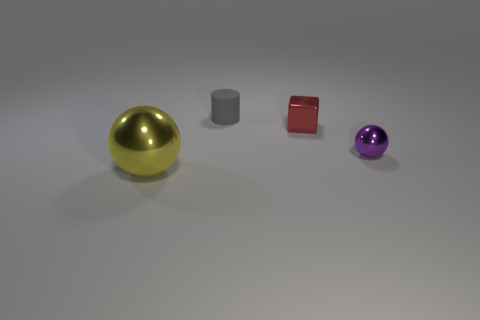What is the block made of?
Your answer should be very brief. Metal. What number of other objects are the same material as the tiny block?
Give a very brief answer. 2. How many red cubes are there?
Give a very brief answer. 1. Is the material of the thing that is in front of the tiny purple metallic ball the same as the tiny red thing?
Offer a very short reply. Yes. Is the number of large metal spheres on the left side of the tiny metallic block greater than the number of cylinders behind the tiny gray thing?
Your answer should be very brief. Yes. The block has what size?
Provide a succinct answer. Small. The purple thing that is the same material as the small block is what shape?
Provide a succinct answer. Sphere. There is a metal thing on the left side of the small gray cylinder; does it have the same shape as the small purple thing?
Make the answer very short. Yes. What number of objects are purple matte cylinders or tiny red metallic blocks?
Offer a very short reply. 1. The thing that is both to the left of the red metal block and behind the yellow metallic thing is made of what material?
Your answer should be very brief. Rubber. 